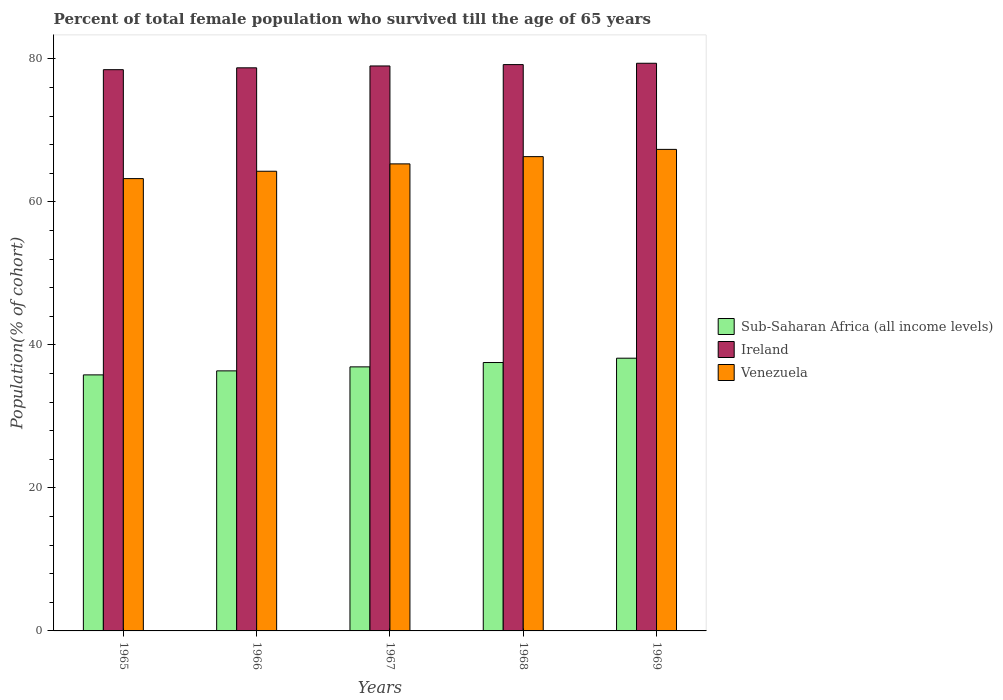How many different coloured bars are there?
Your answer should be very brief. 3. What is the label of the 5th group of bars from the left?
Your response must be concise. 1969. What is the percentage of total female population who survived till the age of 65 years in Sub-Saharan Africa (all income levels) in 1967?
Your answer should be compact. 36.93. Across all years, what is the maximum percentage of total female population who survived till the age of 65 years in Venezuela?
Offer a terse response. 67.34. Across all years, what is the minimum percentage of total female population who survived till the age of 65 years in Venezuela?
Give a very brief answer. 63.26. In which year was the percentage of total female population who survived till the age of 65 years in Ireland maximum?
Provide a succinct answer. 1969. In which year was the percentage of total female population who survived till the age of 65 years in Venezuela minimum?
Keep it short and to the point. 1965. What is the total percentage of total female population who survived till the age of 65 years in Venezuela in the graph?
Offer a terse response. 326.52. What is the difference between the percentage of total female population who survived till the age of 65 years in Sub-Saharan Africa (all income levels) in 1966 and that in 1968?
Your answer should be compact. -1.17. What is the difference between the percentage of total female population who survived till the age of 65 years in Venezuela in 1969 and the percentage of total female population who survived till the age of 65 years in Sub-Saharan Africa (all income levels) in 1967?
Provide a short and direct response. 30.41. What is the average percentage of total female population who survived till the age of 65 years in Venezuela per year?
Offer a terse response. 65.3. In the year 1966, what is the difference between the percentage of total female population who survived till the age of 65 years in Sub-Saharan Africa (all income levels) and percentage of total female population who survived till the age of 65 years in Ireland?
Keep it short and to the point. -42.38. What is the ratio of the percentage of total female population who survived till the age of 65 years in Sub-Saharan Africa (all income levels) in 1965 to that in 1969?
Provide a short and direct response. 0.94. What is the difference between the highest and the second highest percentage of total female population who survived till the age of 65 years in Ireland?
Offer a very short reply. 0.19. What is the difference between the highest and the lowest percentage of total female population who survived till the age of 65 years in Venezuela?
Ensure brevity in your answer.  4.09. In how many years, is the percentage of total female population who survived till the age of 65 years in Ireland greater than the average percentage of total female population who survived till the age of 65 years in Ireland taken over all years?
Your answer should be compact. 3. What does the 1st bar from the left in 1968 represents?
Ensure brevity in your answer.  Sub-Saharan Africa (all income levels). What does the 1st bar from the right in 1967 represents?
Provide a short and direct response. Venezuela. How many bars are there?
Give a very brief answer. 15. How many legend labels are there?
Provide a short and direct response. 3. What is the title of the graph?
Provide a succinct answer. Percent of total female population who survived till the age of 65 years. What is the label or title of the X-axis?
Provide a succinct answer. Years. What is the label or title of the Y-axis?
Your answer should be compact. Population(% of cohort). What is the Population(% of cohort) in Sub-Saharan Africa (all income levels) in 1965?
Your answer should be very brief. 35.81. What is the Population(% of cohort) in Ireland in 1965?
Offer a terse response. 78.49. What is the Population(% of cohort) of Venezuela in 1965?
Keep it short and to the point. 63.26. What is the Population(% of cohort) of Sub-Saharan Africa (all income levels) in 1966?
Your answer should be very brief. 36.37. What is the Population(% of cohort) in Ireland in 1966?
Your response must be concise. 78.75. What is the Population(% of cohort) in Venezuela in 1966?
Provide a short and direct response. 64.28. What is the Population(% of cohort) in Sub-Saharan Africa (all income levels) in 1967?
Make the answer very short. 36.93. What is the Population(% of cohort) of Ireland in 1967?
Ensure brevity in your answer.  79.01. What is the Population(% of cohort) in Venezuela in 1967?
Offer a terse response. 65.31. What is the Population(% of cohort) in Sub-Saharan Africa (all income levels) in 1968?
Keep it short and to the point. 37.53. What is the Population(% of cohort) of Ireland in 1968?
Provide a short and direct response. 79.2. What is the Population(% of cohort) in Venezuela in 1968?
Make the answer very short. 66.33. What is the Population(% of cohort) of Sub-Saharan Africa (all income levels) in 1969?
Offer a terse response. 38.14. What is the Population(% of cohort) in Ireland in 1969?
Provide a succinct answer. 79.39. What is the Population(% of cohort) in Venezuela in 1969?
Make the answer very short. 67.34. Across all years, what is the maximum Population(% of cohort) of Sub-Saharan Africa (all income levels)?
Make the answer very short. 38.14. Across all years, what is the maximum Population(% of cohort) in Ireland?
Provide a succinct answer. 79.39. Across all years, what is the maximum Population(% of cohort) in Venezuela?
Keep it short and to the point. 67.34. Across all years, what is the minimum Population(% of cohort) of Sub-Saharan Africa (all income levels)?
Offer a very short reply. 35.81. Across all years, what is the minimum Population(% of cohort) of Ireland?
Your response must be concise. 78.49. Across all years, what is the minimum Population(% of cohort) of Venezuela?
Give a very brief answer. 63.26. What is the total Population(% of cohort) of Sub-Saharan Africa (all income levels) in the graph?
Keep it short and to the point. 184.77. What is the total Population(% of cohort) of Ireland in the graph?
Offer a very short reply. 394.83. What is the total Population(% of cohort) of Venezuela in the graph?
Keep it short and to the point. 326.52. What is the difference between the Population(% of cohort) in Sub-Saharan Africa (all income levels) in 1965 and that in 1966?
Give a very brief answer. -0.56. What is the difference between the Population(% of cohort) of Ireland in 1965 and that in 1966?
Keep it short and to the point. -0.26. What is the difference between the Population(% of cohort) of Venezuela in 1965 and that in 1966?
Your response must be concise. -1.03. What is the difference between the Population(% of cohort) in Sub-Saharan Africa (all income levels) in 1965 and that in 1967?
Ensure brevity in your answer.  -1.12. What is the difference between the Population(% of cohort) in Ireland in 1965 and that in 1967?
Keep it short and to the point. -0.52. What is the difference between the Population(% of cohort) in Venezuela in 1965 and that in 1967?
Keep it short and to the point. -2.06. What is the difference between the Population(% of cohort) of Sub-Saharan Africa (all income levels) in 1965 and that in 1968?
Your response must be concise. -1.73. What is the difference between the Population(% of cohort) of Ireland in 1965 and that in 1968?
Keep it short and to the point. -0.71. What is the difference between the Population(% of cohort) in Venezuela in 1965 and that in 1968?
Offer a very short reply. -3.07. What is the difference between the Population(% of cohort) of Sub-Saharan Africa (all income levels) in 1965 and that in 1969?
Ensure brevity in your answer.  -2.33. What is the difference between the Population(% of cohort) in Ireland in 1965 and that in 1969?
Your answer should be compact. -0.9. What is the difference between the Population(% of cohort) of Venezuela in 1965 and that in 1969?
Make the answer very short. -4.09. What is the difference between the Population(% of cohort) of Sub-Saharan Africa (all income levels) in 1966 and that in 1967?
Offer a very short reply. -0.56. What is the difference between the Population(% of cohort) in Ireland in 1966 and that in 1967?
Provide a succinct answer. -0.26. What is the difference between the Population(% of cohort) in Venezuela in 1966 and that in 1967?
Ensure brevity in your answer.  -1.03. What is the difference between the Population(% of cohort) of Sub-Saharan Africa (all income levels) in 1966 and that in 1968?
Provide a short and direct response. -1.17. What is the difference between the Population(% of cohort) in Ireland in 1966 and that in 1968?
Offer a terse response. -0.45. What is the difference between the Population(% of cohort) of Venezuela in 1966 and that in 1968?
Your answer should be very brief. -2.04. What is the difference between the Population(% of cohort) in Sub-Saharan Africa (all income levels) in 1966 and that in 1969?
Ensure brevity in your answer.  -1.77. What is the difference between the Population(% of cohort) of Ireland in 1966 and that in 1969?
Your answer should be very brief. -0.64. What is the difference between the Population(% of cohort) of Venezuela in 1966 and that in 1969?
Make the answer very short. -3.06. What is the difference between the Population(% of cohort) of Sub-Saharan Africa (all income levels) in 1967 and that in 1968?
Offer a very short reply. -0.61. What is the difference between the Population(% of cohort) in Ireland in 1967 and that in 1968?
Ensure brevity in your answer.  -0.19. What is the difference between the Population(% of cohort) in Venezuela in 1967 and that in 1968?
Offer a terse response. -1.01. What is the difference between the Population(% of cohort) in Sub-Saharan Africa (all income levels) in 1967 and that in 1969?
Provide a short and direct response. -1.21. What is the difference between the Population(% of cohort) of Ireland in 1967 and that in 1969?
Give a very brief answer. -0.38. What is the difference between the Population(% of cohort) of Venezuela in 1967 and that in 1969?
Your answer should be compact. -2.03. What is the difference between the Population(% of cohort) in Sub-Saharan Africa (all income levels) in 1968 and that in 1969?
Ensure brevity in your answer.  -0.61. What is the difference between the Population(% of cohort) in Ireland in 1968 and that in 1969?
Offer a very short reply. -0.19. What is the difference between the Population(% of cohort) in Venezuela in 1968 and that in 1969?
Make the answer very short. -1.01. What is the difference between the Population(% of cohort) of Sub-Saharan Africa (all income levels) in 1965 and the Population(% of cohort) of Ireland in 1966?
Keep it short and to the point. -42.94. What is the difference between the Population(% of cohort) of Sub-Saharan Africa (all income levels) in 1965 and the Population(% of cohort) of Venezuela in 1966?
Your response must be concise. -28.48. What is the difference between the Population(% of cohort) in Ireland in 1965 and the Population(% of cohort) in Venezuela in 1966?
Give a very brief answer. 14.2. What is the difference between the Population(% of cohort) in Sub-Saharan Africa (all income levels) in 1965 and the Population(% of cohort) in Ireland in 1967?
Ensure brevity in your answer.  -43.2. What is the difference between the Population(% of cohort) in Sub-Saharan Africa (all income levels) in 1965 and the Population(% of cohort) in Venezuela in 1967?
Keep it short and to the point. -29.51. What is the difference between the Population(% of cohort) in Ireland in 1965 and the Population(% of cohort) in Venezuela in 1967?
Make the answer very short. 13.17. What is the difference between the Population(% of cohort) of Sub-Saharan Africa (all income levels) in 1965 and the Population(% of cohort) of Ireland in 1968?
Ensure brevity in your answer.  -43.39. What is the difference between the Population(% of cohort) of Sub-Saharan Africa (all income levels) in 1965 and the Population(% of cohort) of Venezuela in 1968?
Provide a succinct answer. -30.52. What is the difference between the Population(% of cohort) of Ireland in 1965 and the Population(% of cohort) of Venezuela in 1968?
Your answer should be compact. 12.16. What is the difference between the Population(% of cohort) of Sub-Saharan Africa (all income levels) in 1965 and the Population(% of cohort) of Ireland in 1969?
Ensure brevity in your answer.  -43.58. What is the difference between the Population(% of cohort) of Sub-Saharan Africa (all income levels) in 1965 and the Population(% of cohort) of Venezuela in 1969?
Offer a very short reply. -31.54. What is the difference between the Population(% of cohort) in Ireland in 1965 and the Population(% of cohort) in Venezuela in 1969?
Provide a succinct answer. 11.14. What is the difference between the Population(% of cohort) in Sub-Saharan Africa (all income levels) in 1966 and the Population(% of cohort) in Ireland in 1967?
Your answer should be compact. -42.64. What is the difference between the Population(% of cohort) of Sub-Saharan Africa (all income levels) in 1966 and the Population(% of cohort) of Venezuela in 1967?
Provide a succinct answer. -28.95. What is the difference between the Population(% of cohort) of Ireland in 1966 and the Population(% of cohort) of Venezuela in 1967?
Offer a terse response. 13.43. What is the difference between the Population(% of cohort) in Sub-Saharan Africa (all income levels) in 1966 and the Population(% of cohort) in Ireland in 1968?
Provide a succinct answer. -42.83. What is the difference between the Population(% of cohort) in Sub-Saharan Africa (all income levels) in 1966 and the Population(% of cohort) in Venezuela in 1968?
Give a very brief answer. -29.96. What is the difference between the Population(% of cohort) of Ireland in 1966 and the Population(% of cohort) of Venezuela in 1968?
Make the answer very short. 12.42. What is the difference between the Population(% of cohort) in Sub-Saharan Africa (all income levels) in 1966 and the Population(% of cohort) in Ireland in 1969?
Give a very brief answer. -43.02. What is the difference between the Population(% of cohort) in Sub-Saharan Africa (all income levels) in 1966 and the Population(% of cohort) in Venezuela in 1969?
Make the answer very short. -30.98. What is the difference between the Population(% of cohort) in Ireland in 1966 and the Population(% of cohort) in Venezuela in 1969?
Keep it short and to the point. 11.41. What is the difference between the Population(% of cohort) in Sub-Saharan Africa (all income levels) in 1967 and the Population(% of cohort) in Ireland in 1968?
Give a very brief answer. -42.27. What is the difference between the Population(% of cohort) in Sub-Saharan Africa (all income levels) in 1967 and the Population(% of cohort) in Venezuela in 1968?
Your response must be concise. -29.4. What is the difference between the Population(% of cohort) in Ireland in 1967 and the Population(% of cohort) in Venezuela in 1968?
Provide a short and direct response. 12.68. What is the difference between the Population(% of cohort) of Sub-Saharan Africa (all income levels) in 1967 and the Population(% of cohort) of Ireland in 1969?
Provide a succinct answer. -42.46. What is the difference between the Population(% of cohort) in Sub-Saharan Africa (all income levels) in 1967 and the Population(% of cohort) in Venezuela in 1969?
Offer a terse response. -30.41. What is the difference between the Population(% of cohort) of Ireland in 1967 and the Population(% of cohort) of Venezuela in 1969?
Offer a very short reply. 11.67. What is the difference between the Population(% of cohort) in Sub-Saharan Africa (all income levels) in 1968 and the Population(% of cohort) in Ireland in 1969?
Provide a succinct answer. -41.85. What is the difference between the Population(% of cohort) of Sub-Saharan Africa (all income levels) in 1968 and the Population(% of cohort) of Venezuela in 1969?
Keep it short and to the point. -29.81. What is the difference between the Population(% of cohort) in Ireland in 1968 and the Population(% of cohort) in Venezuela in 1969?
Give a very brief answer. 11.86. What is the average Population(% of cohort) of Sub-Saharan Africa (all income levels) per year?
Ensure brevity in your answer.  36.95. What is the average Population(% of cohort) in Ireland per year?
Provide a succinct answer. 78.97. What is the average Population(% of cohort) in Venezuela per year?
Keep it short and to the point. 65.31. In the year 1965, what is the difference between the Population(% of cohort) of Sub-Saharan Africa (all income levels) and Population(% of cohort) of Ireland?
Keep it short and to the point. -42.68. In the year 1965, what is the difference between the Population(% of cohort) of Sub-Saharan Africa (all income levels) and Population(% of cohort) of Venezuela?
Make the answer very short. -27.45. In the year 1965, what is the difference between the Population(% of cohort) of Ireland and Population(% of cohort) of Venezuela?
Your response must be concise. 15.23. In the year 1966, what is the difference between the Population(% of cohort) in Sub-Saharan Africa (all income levels) and Population(% of cohort) in Ireland?
Your answer should be very brief. -42.38. In the year 1966, what is the difference between the Population(% of cohort) of Sub-Saharan Africa (all income levels) and Population(% of cohort) of Venezuela?
Give a very brief answer. -27.92. In the year 1966, what is the difference between the Population(% of cohort) in Ireland and Population(% of cohort) in Venezuela?
Give a very brief answer. 14.46. In the year 1967, what is the difference between the Population(% of cohort) in Sub-Saharan Africa (all income levels) and Population(% of cohort) in Ireland?
Your response must be concise. -42.08. In the year 1967, what is the difference between the Population(% of cohort) in Sub-Saharan Africa (all income levels) and Population(% of cohort) in Venezuela?
Provide a short and direct response. -28.39. In the year 1967, what is the difference between the Population(% of cohort) of Ireland and Population(% of cohort) of Venezuela?
Provide a short and direct response. 13.69. In the year 1968, what is the difference between the Population(% of cohort) of Sub-Saharan Africa (all income levels) and Population(% of cohort) of Ireland?
Your response must be concise. -41.66. In the year 1968, what is the difference between the Population(% of cohort) in Sub-Saharan Africa (all income levels) and Population(% of cohort) in Venezuela?
Your answer should be compact. -28.79. In the year 1968, what is the difference between the Population(% of cohort) in Ireland and Population(% of cohort) in Venezuela?
Your answer should be compact. 12.87. In the year 1969, what is the difference between the Population(% of cohort) in Sub-Saharan Africa (all income levels) and Population(% of cohort) in Ireland?
Provide a succinct answer. -41.25. In the year 1969, what is the difference between the Population(% of cohort) of Sub-Saharan Africa (all income levels) and Population(% of cohort) of Venezuela?
Your answer should be very brief. -29.2. In the year 1969, what is the difference between the Population(% of cohort) of Ireland and Population(% of cohort) of Venezuela?
Your answer should be very brief. 12.04. What is the ratio of the Population(% of cohort) in Sub-Saharan Africa (all income levels) in 1965 to that in 1966?
Keep it short and to the point. 0.98. What is the ratio of the Population(% of cohort) in Ireland in 1965 to that in 1966?
Make the answer very short. 1. What is the ratio of the Population(% of cohort) of Sub-Saharan Africa (all income levels) in 1965 to that in 1967?
Ensure brevity in your answer.  0.97. What is the ratio of the Population(% of cohort) of Ireland in 1965 to that in 1967?
Ensure brevity in your answer.  0.99. What is the ratio of the Population(% of cohort) of Venezuela in 1965 to that in 1967?
Make the answer very short. 0.97. What is the ratio of the Population(% of cohort) in Sub-Saharan Africa (all income levels) in 1965 to that in 1968?
Offer a very short reply. 0.95. What is the ratio of the Population(% of cohort) of Venezuela in 1965 to that in 1968?
Provide a short and direct response. 0.95. What is the ratio of the Population(% of cohort) in Sub-Saharan Africa (all income levels) in 1965 to that in 1969?
Offer a very short reply. 0.94. What is the ratio of the Population(% of cohort) in Ireland in 1965 to that in 1969?
Make the answer very short. 0.99. What is the ratio of the Population(% of cohort) in Venezuela in 1965 to that in 1969?
Your answer should be compact. 0.94. What is the ratio of the Population(% of cohort) in Sub-Saharan Africa (all income levels) in 1966 to that in 1967?
Your answer should be compact. 0.98. What is the ratio of the Population(% of cohort) of Ireland in 1966 to that in 1967?
Your answer should be very brief. 1. What is the ratio of the Population(% of cohort) in Venezuela in 1966 to that in 1967?
Your answer should be compact. 0.98. What is the ratio of the Population(% of cohort) in Sub-Saharan Africa (all income levels) in 1966 to that in 1968?
Your answer should be very brief. 0.97. What is the ratio of the Population(% of cohort) of Venezuela in 1966 to that in 1968?
Provide a succinct answer. 0.97. What is the ratio of the Population(% of cohort) in Sub-Saharan Africa (all income levels) in 1966 to that in 1969?
Keep it short and to the point. 0.95. What is the ratio of the Population(% of cohort) of Venezuela in 1966 to that in 1969?
Your response must be concise. 0.95. What is the ratio of the Population(% of cohort) of Sub-Saharan Africa (all income levels) in 1967 to that in 1968?
Offer a very short reply. 0.98. What is the ratio of the Population(% of cohort) in Ireland in 1967 to that in 1968?
Ensure brevity in your answer.  1. What is the ratio of the Population(% of cohort) of Venezuela in 1967 to that in 1968?
Offer a terse response. 0.98. What is the ratio of the Population(% of cohort) of Sub-Saharan Africa (all income levels) in 1967 to that in 1969?
Offer a very short reply. 0.97. What is the ratio of the Population(% of cohort) in Venezuela in 1967 to that in 1969?
Your answer should be compact. 0.97. What is the ratio of the Population(% of cohort) of Sub-Saharan Africa (all income levels) in 1968 to that in 1969?
Offer a terse response. 0.98. What is the ratio of the Population(% of cohort) of Ireland in 1968 to that in 1969?
Make the answer very short. 1. What is the ratio of the Population(% of cohort) of Venezuela in 1968 to that in 1969?
Provide a succinct answer. 0.98. What is the difference between the highest and the second highest Population(% of cohort) of Sub-Saharan Africa (all income levels)?
Give a very brief answer. 0.61. What is the difference between the highest and the second highest Population(% of cohort) of Ireland?
Provide a succinct answer. 0.19. What is the difference between the highest and the second highest Population(% of cohort) in Venezuela?
Your answer should be compact. 1.01. What is the difference between the highest and the lowest Population(% of cohort) of Sub-Saharan Africa (all income levels)?
Your answer should be very brief. 2.33. What is the difference between the highest and the lowest Population(% of cohort) in Ireland?
Provide a short and direct response. 0.9. What is the difference between the highest and the lowest Population(% of cohort) of Venezuela?
Make the answer very short. 4.09. 